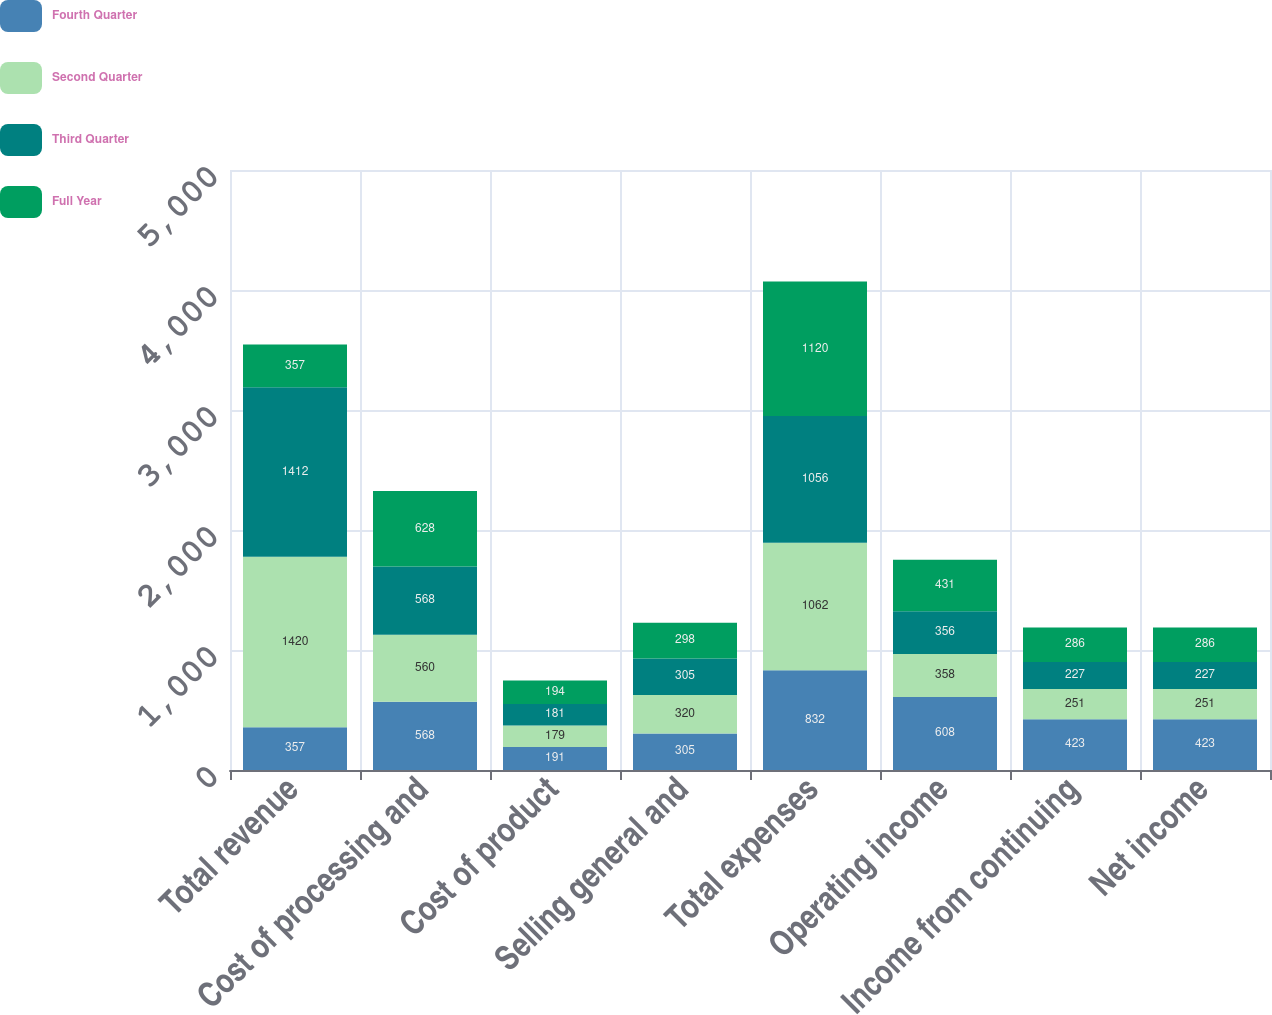Convert chart to OTSL. <chart><loc_0><loc_0><loc_500><loc_500><stacked_bar_chart><ecel><fcel>Total revenue<fcel>Cost of processing and<fcel>Cost of product<fcel>Selling general and<fcel>Total expenses<fcel>Operating income<fcel>Income from continuing<fcel>Net income<nl><fcel>Fourth Quarter<fcel>357<fcel>568<fcel>191<fcel>305<fcel>832<fcel>608<fcel>423<fcel>423<nl><fcel>Second Quarter<fcel>1420<fcel>560<fcel>179<fcel>320<fcel>1062<fcel>358<fcel>251<fcel>251<nl><fcel>Third Quarter<fcel>1412<fcel>568<fcel>181<fcel>305<fcel>1056<fcel>356<fcel>227<fcel>227<nl><fcel>Full Year<fcel>357<fcel>628<fcel>194<fcel>298<fcel>1120<fcel>431<fcel>286<fcel>286<nl></chart> 